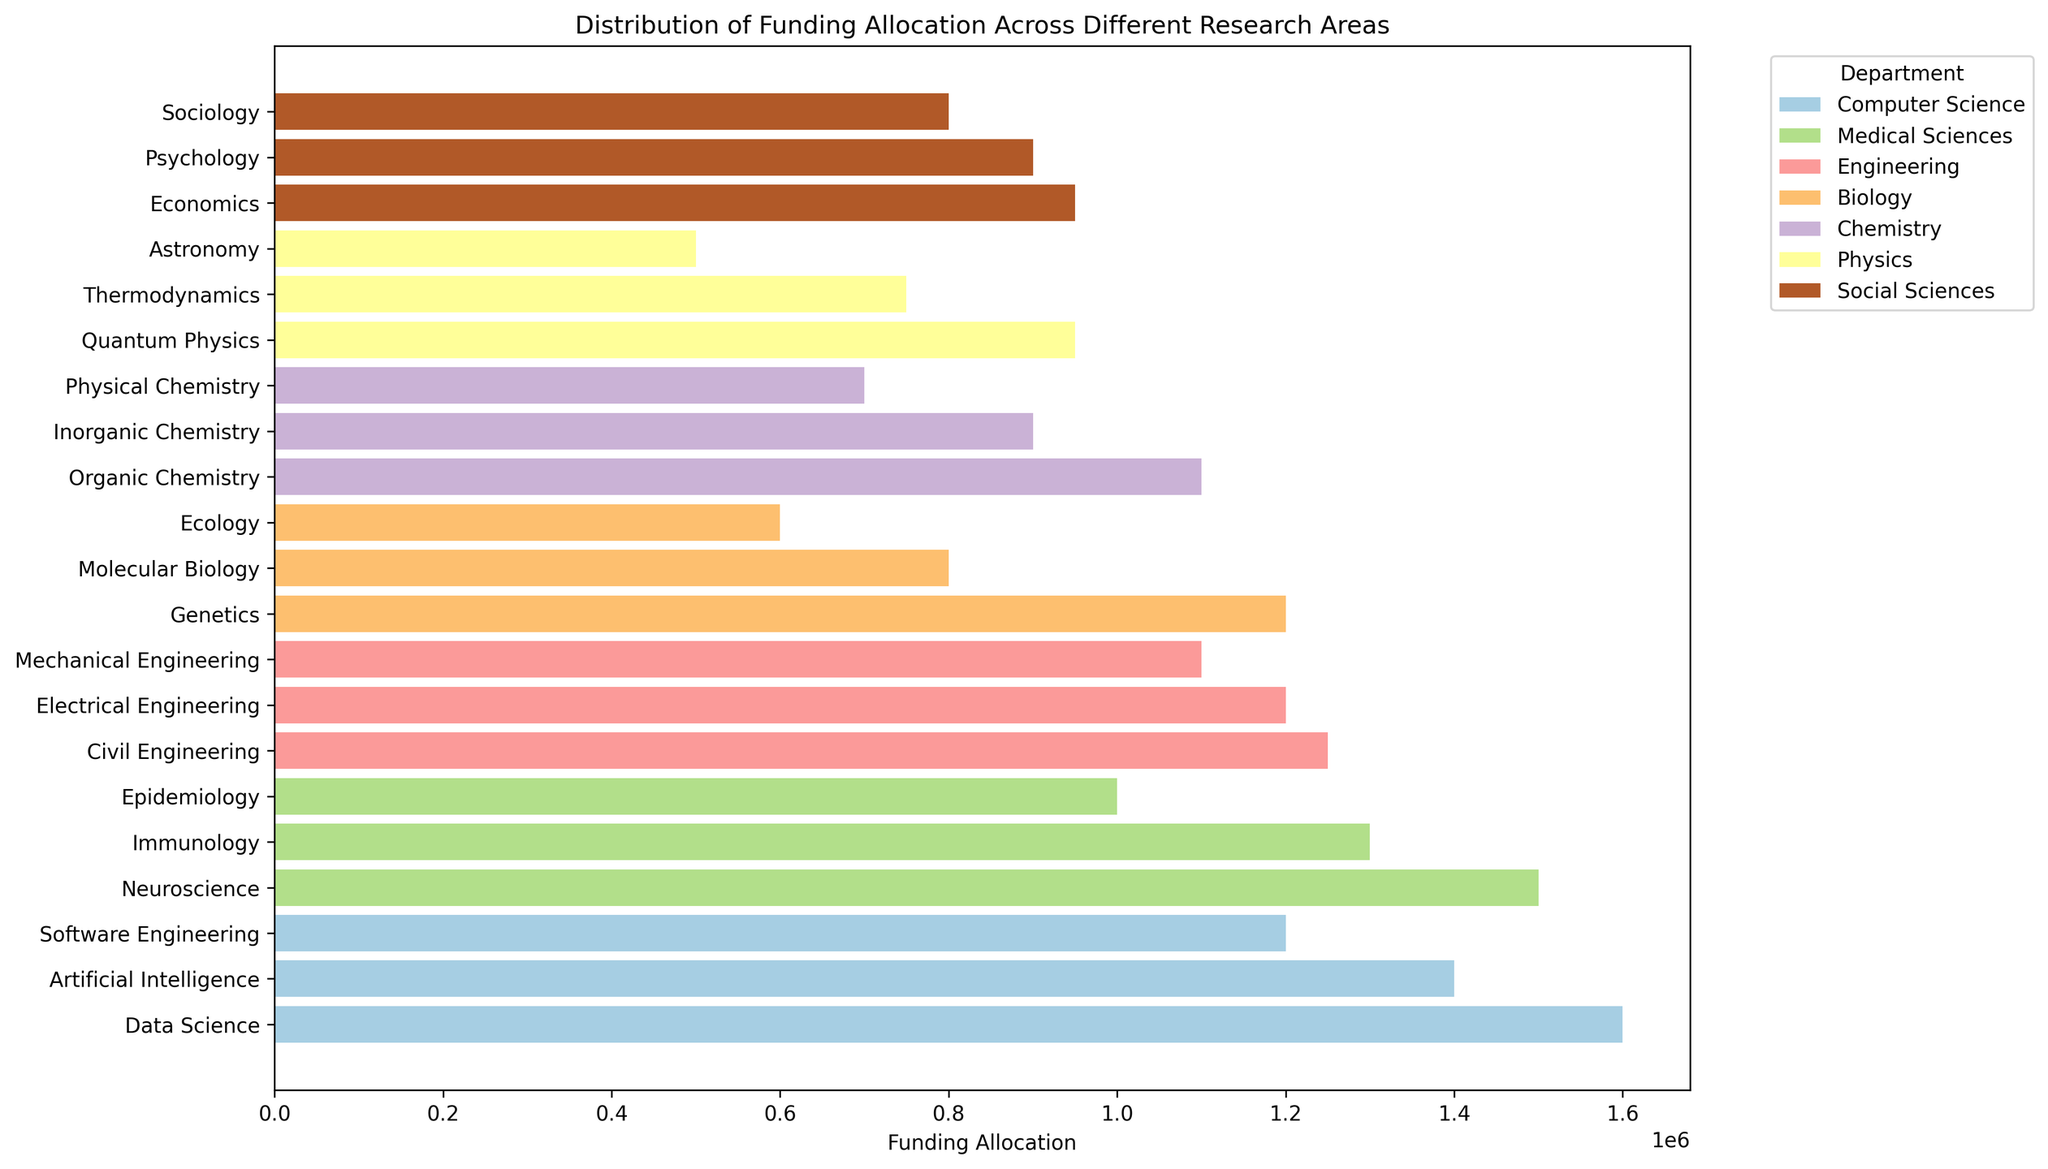Which department has the highest total funding allocation? To determine the department with the highest total funding, sum the funding allocations for each research area within each department. Compare the totals and identify the department with the highest sum. The department with the highest total funding allocation is Medical Sciences with: Immunology (1300000) + Neuroscience (1500000) + Epidemiology (1000000) = 3800000.
Answer: Medical Sciences Which research area received the highest individual funding allocation? Look at the bar lengths and labels to identify the research area with the longest bar, representing the highest funding allocation. Data Science in Computer Science shows the highest funding allocation of 1600000.
Answer: Data Science How does the funding allocation for Genetics compare with that for Neuroscience? Locate the bars for Genetics and Neuroscience and compare their lengths (encoded funding). Genetics in Biology is 1200000, while Neuroscience in Medical Sciences is 1500000. The allocation for Neuroscience is greater.
Answer: Neuroscience has more funding What is the combined funding allocation for Psychology and Sociology? Find the bars for both Psychology and Sociology in Social Sciences and sum their respective funding allocations. Psychology: 900000 + Sociology: 800000 = 1700000.
Answer: 1700000 Which department has the most evenly distributed funding allocation across its research areas? Compare the range and standard deviation of the funding allocations within each department. The department with the closest lengths of bars (smallest differences) will have the most even distribution. Engineering has Mechanical Engineering (1100000), Electrical Engineering (1200000), and Civil Engineering (1250000) with small differences.
Answer: Engineering Which research area in the Physics department received the least funding? Identify the department Biology and compare the bar lengths for each research area. Astronomy has the smallest bar with a funding allocation of 500000.
Answer: Astronomy Is the funding allocation for Organic Chemistry higher than for Quantum Physics? Compare the bar lengths for Organic Chemistry in Chemistry and Quantum Physics in Physics. Organic Chemistry (1100000) is greater than Quantum Physics (950000).
Answer: Yes What is the difference in funding allocation between Artificial Intelligence and Software Engineering in Computer Science? Calculate the difference in the heights of the bars for both areas. Artificial Intelligence: 1400000 - Software Engineering: 120000 = 200000.
Answer: 200000 Which department has the highest combined funding allocation for all its research areas related to health and medical sciences? Find the sum of the funding allocations for research areas within the Medical Sciences department. Immunology (1300000) + Neuroscience (1500000) + Epidemiology (1000000) = 3800000.
Answer: Medical Sciences 